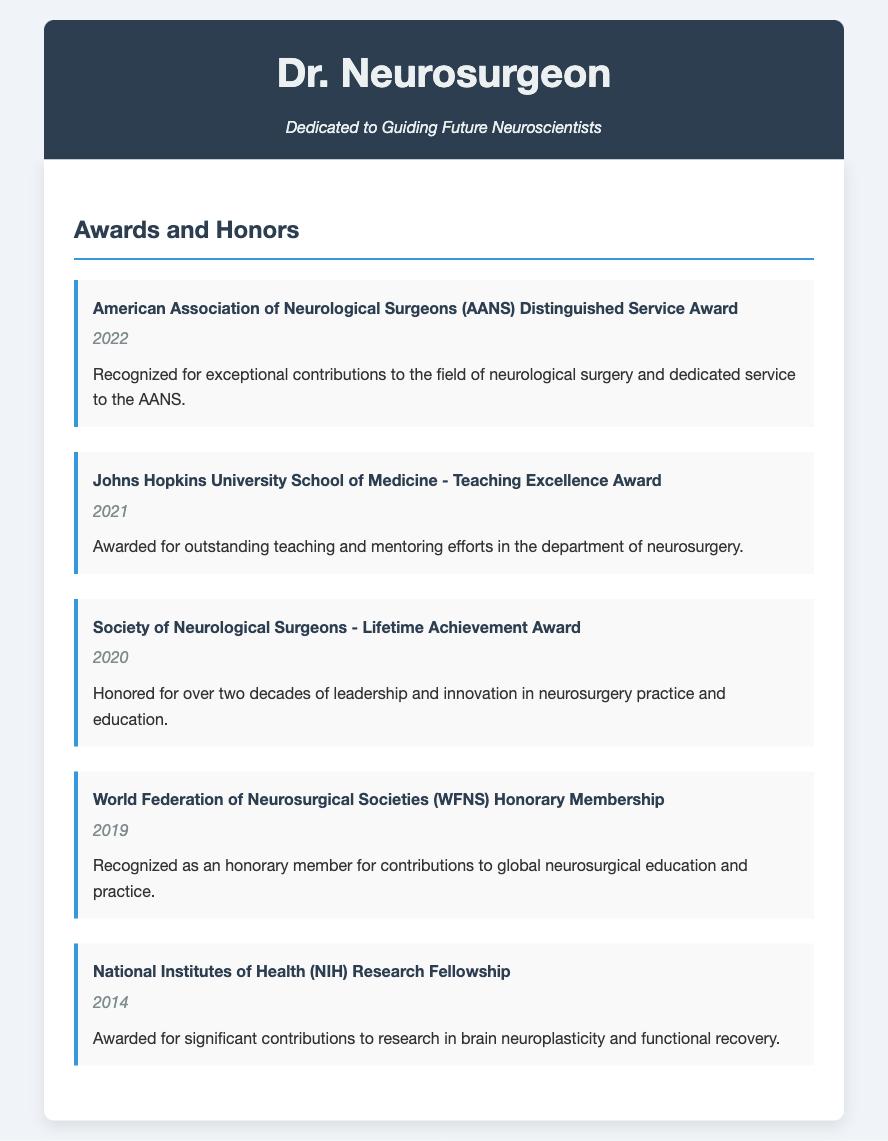What was the year of the AANS Distinguished Service Award? The award was given in the year mentioned in the document under the specific award section.
Answer: 2022 Which university awarded the Teaching Excellence Award? The award is associated with a specific university mentioned in the document.
Answer: Johns Hopkins University School of Medicine What is the title of the award received in 2020? This title can be found in the corresponding section for that year.
Answer: Lifetime Achievement Award Which organization awarded the Honorary Membership? The document states which organization granted this recognition.
Answer: World Federation of Neurosurgical Societies In what year did you receive the NIH Research Fellowship? This year is specified in the description of the award in the document.
Answer: 2014 What notable contribution was recognized with the AANS Distinguished Service Award? The description under the award mentions specific contributions that led to the recognition.
Answer: Exceptional contributions to the field of neurological surgery How many awards are listed in the document? The total number of awards stated can be counted from the document section.
Answer: Five What is the common theme for the awards mentioned in the document? The awards relate to specific aspects of the field of neurosurgery and education as indicated throughout.
Answer: Contributions to neurosurgery and education 